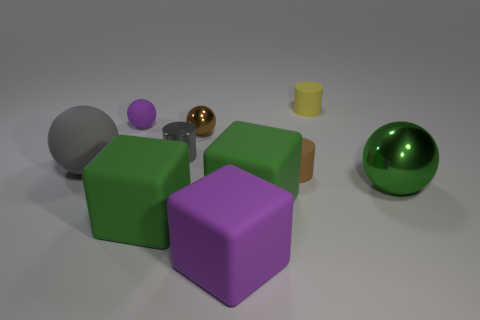Is the brown ball the same size as the shiny cylinder?
Provide a short and direct response. Yes. What is the material of the small object that is to the left of the gray metallic object?
Ensure brevity in your answer.  Rubber. What number of other objects are there of the same shape as the small gray object?
Make the answer very short. 2. Does the small gray metal object have the same shape as the gray rubber thing?
Your response must be concise. No. There is a brown cylinder; are there any large green spheres behind it?
Your response must be concise. No. How many objects are small green metal blocks or tiny brown balls?
Your answer should be very brief. 1. What number of other objects are the same size as the brown ball?
Your answer should be very brief. 4. What number of rubber objects are both right of the metallic cylinder and in front of the small gray cylinder?
Offer a very short reply. 3. Is the size of the metallic sphere that is on the left side of the green metal ball the same as the purple matte thing in front of the purple rubber ball?
Provide a succinct answer. No. There is a purple thing that is in front of the tiny gray metal object; what is its size?
Make the answer very short. Large. 